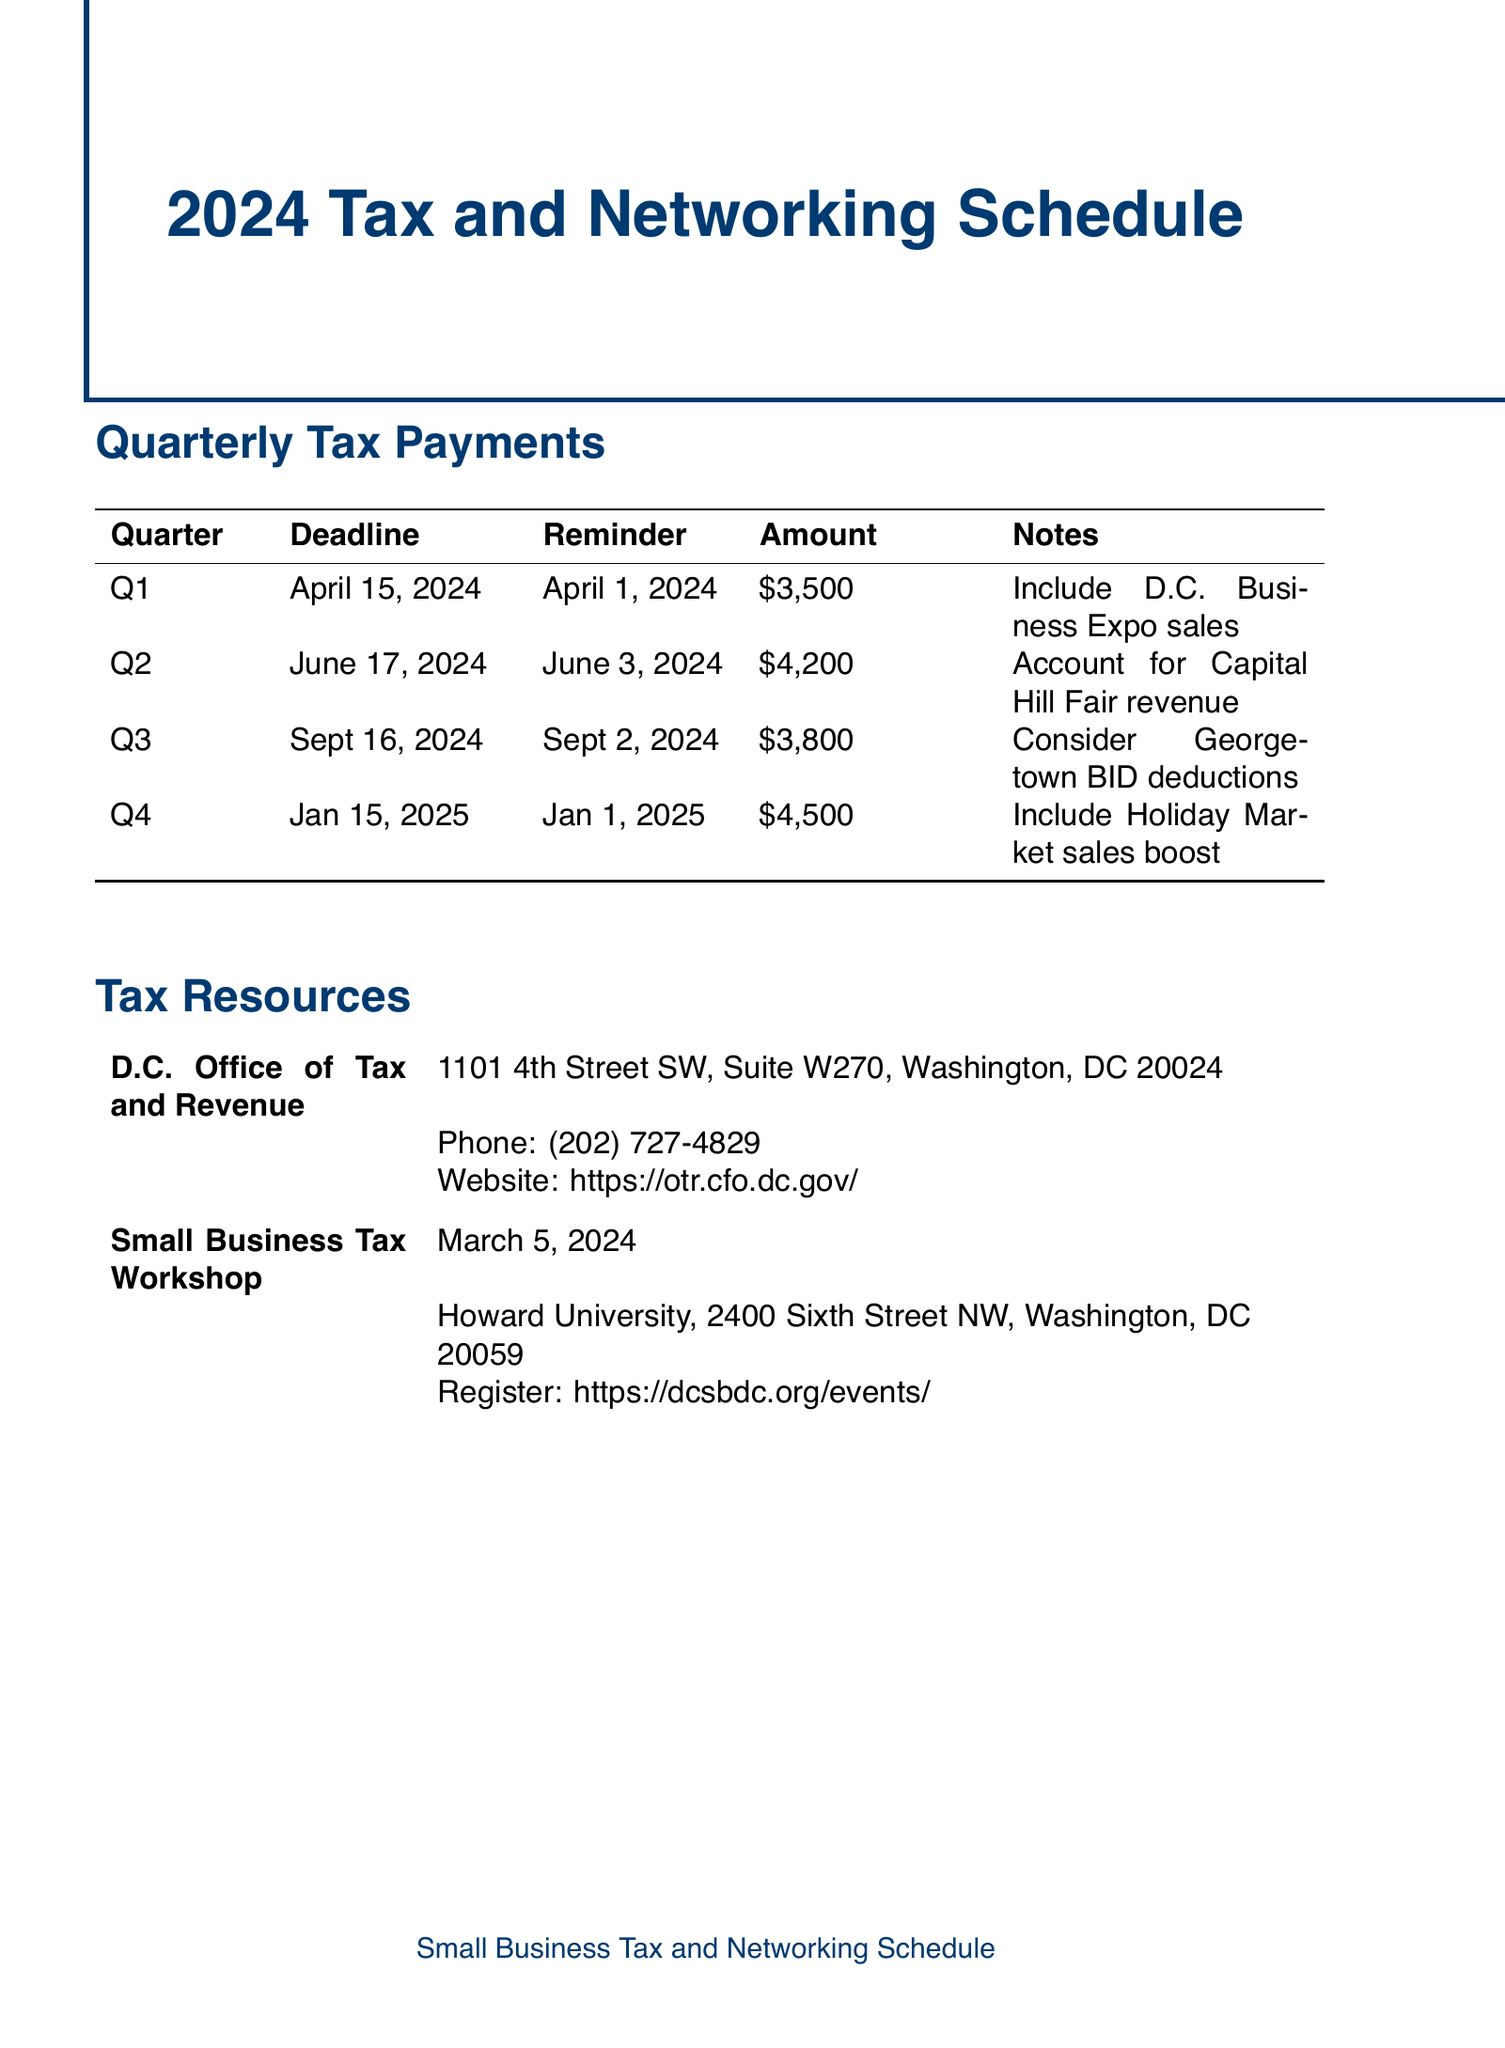What is the deadline for Q1? The deadline for Q1 is specified in the document, corresponding with the first quarter's schedule.
Answer: April 15, 2024 What is the estimated amount for Q3? The estimated amount for Q3 is listed under the quarterly tax payments section of the document.
Answer: 3800 When is the reminder for Q2? The reminder date for Q2 can be found alongside the deadline in the quarterly tax schedule.
Answer: June 3, 2024 What is the location for the Small Business Tax Workshop? The location is given in the tax resources section of the document, detailing where the workshop will be held.
Answer: Howard University, 2400 Sixth Street NW, Washington, DC 20059 What is the cost for the D.C. Chamber of Commerce Networking Breakfast? The cost is noted next to the event details in the networking events section of the document.
Answer: 45 What is the registration deadline for the Small Business Network Happy Hour? The registration deadline for the Small Business Network Happy Hour can be found in the networking events section.
Answer: No registration deadline mentioned Which payment method is used for Q4? The payment method for Q4 is specified in the quarterly tax payments section.
Answer: EFTPS (Electronic Federal Tax Payment System) How much is the estimated amount for Q2? The estimated amount for Q2 is mentioned in the document under the corresponding quarter's payment details.
Answer: 4200 What event is scheduled for May 8, 2024? The event on that date is part of the networking events listed in the document.
Answer: D.C. Chamber of Commerce Networking Breakfast 